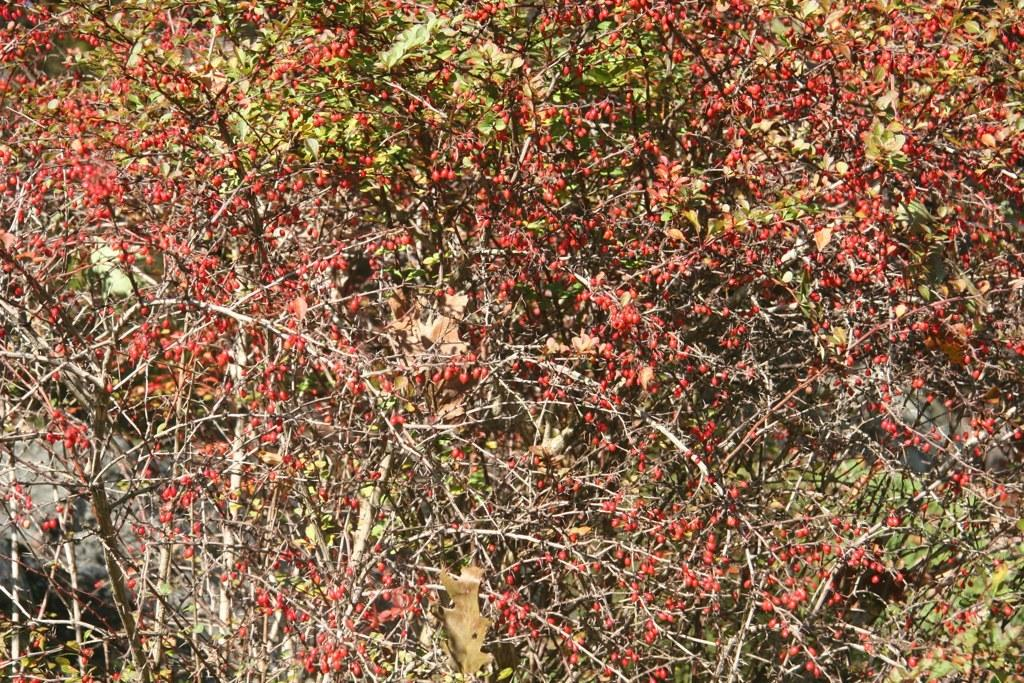What type of plant material can be seen in the image? There are leaves in the image. What else can be found among the leaves in the image? There are fruits in the image. What type of writing instrument is being used by the aunt during the protest in the image? There is no aunt, protest, or quill present in the image; it only features leaves and fruits. 